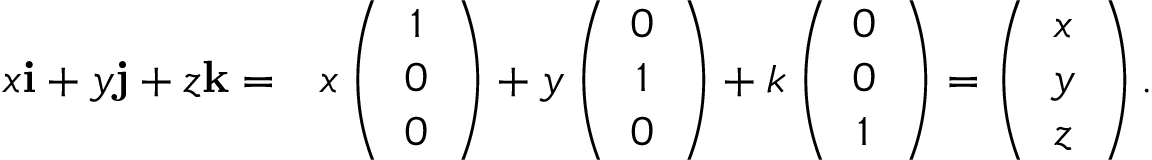Convert formula to latex. <formula><loc_0><loc_0><loc_500><loc_500>\begin{array} { r l } { x { \mathbf i } + y { \mathbf j } + z { \mathbf k } = } & { x \left ( \begin{array} { c } { 1 } \\ { 0 } \\ { 0 } \end{array} \right ) + y \left ( \begin{array} { c } { 0 } \\ { 1 } \\ { 0 } \end{array} \right ) + k \left ( \begin{array} { c } { 0 } \\ { 0 } \\ { 1 } \end{array} \right ) = \left ( \begin{array} { c } { x } \\ { y } \\ { z } \end{array} \right ) . } \end{array}</formula> 